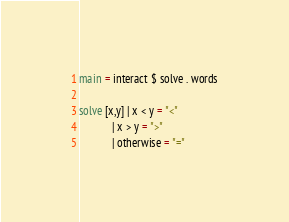Convert code to text. <code><loc_0><loc_0><loc_500><loc_500><_Haskell_>main = interact $ solve . words

solve [x,y] | x < y = "<"
            | x > y = ">"
            | otherwise = "="</code> 